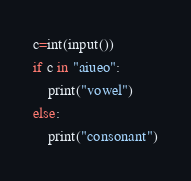<code> <loc_0><loc_0><loc_500><loc_500><_Python_>c=int(input())
if c in "aiueo":
    print("vowel")
else:
    print("consonant")</code> 